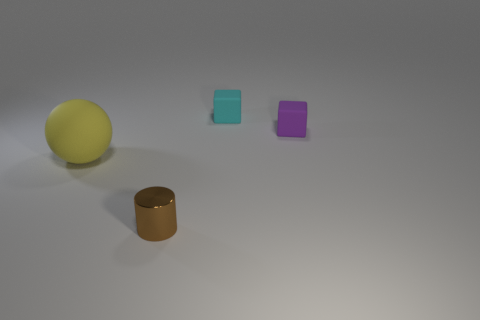How many matte things are to the right of the large yellow rubber thing that is in front of the purple block?
Provide a succinct answer. 2. What number of other objects are there of the same shape as the tiny purple object?
Offer a terse response. 1. How many things are either yellow things or rubber objects on the right side of the small cylinder?
Your answer should be compact. 3. Is the number of purple objects that are behind the tiny cylinder greater than the number of brown cylinders on the left side of the large sphere?
Give a very brief answer. Yes. What is the shape of the small object that is in front of the thing to the left of the thing in front of the big thing?
Your response must be concise. Cylinder. What shape is the rubber object to the left of the tiny thing that is in front of the big rubber object?
Make the answer very short. Sphere. Are there any small things made of the same material as the small cyan block?
Provide a succinct answer. Yes. What number of gray objects are matte objects or big metallic cylinders?
Give a very brief answer. 0. What is the size of the yellow ball that is the same material as the small purple block?
Your answer should be very brief. Large. What number of blocks are tiny gray matte objects or big yellow objects?
Provide a succinct answer. 0. 